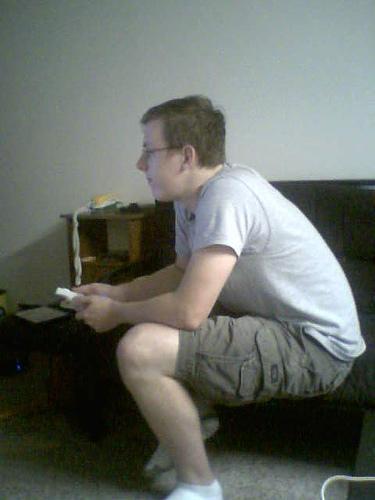How many people are there?
Give a very brief answer. 1. 